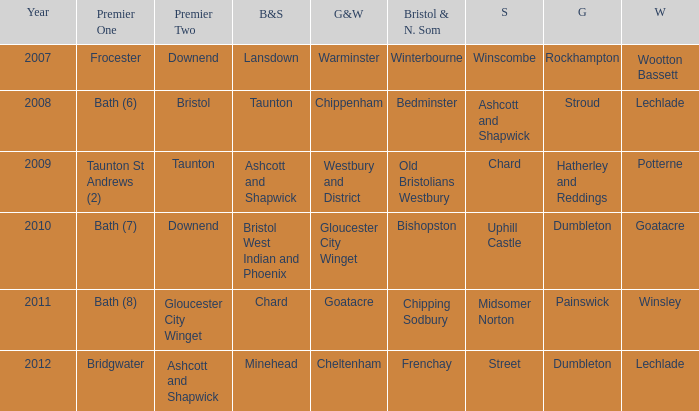What is the glos & wilts where the bristol & somerset is lansdown? Warminster. Would you be able to parse every entry in this table? {'header': ['Year', 'Premier One', 'Premier Two', 'B&S', 'G&W', 'Bristol & N. Som', 'S', 'G', 'W'], 'rows': [['2007', 'Frocester', 'Downend', 'Lansdown', 'Warminster', 'Winterbourne', 'Winscombe', 'Rockhampton', 'Wootton Bassett'], ['2008', 'Bath (6)', 'Bristol', 'Taunton', 'Chippenham', 'Bedminster', 'Ashcott and Shapwick', 'Stroud', 'Lechlade'], ['2009', 'Taunton St Andrews (2)', 'Taunton', 'Ashcott and Shapwick', 'Westbury and District', 'Old Bristolians Westbury', 'Chard', 'Hatherley and Reddings', 'Potterne'], ['2010', 'Bath (7)', 'Downend', 'Bristol West Indian and Phoenix', 'Gloucester City Winget', 'Bishopston', 'Uphill Castle', 'Dumbleton', 'Goatacre'], ['2011', 'Bath (8)', 'Gloucester City Winget', 'Chard', 'Goatacre', 'Chipping Sodbury', 'Midsomer Norton', 'Painswick', 'Winsley'], ['2012', 'Bridgwater', 'Ashcott and Shapwick', 'Minehead', 'Cheltenham', 'Frenchay', 'Street', 'Dumbleton', 'Lechlade']]} 